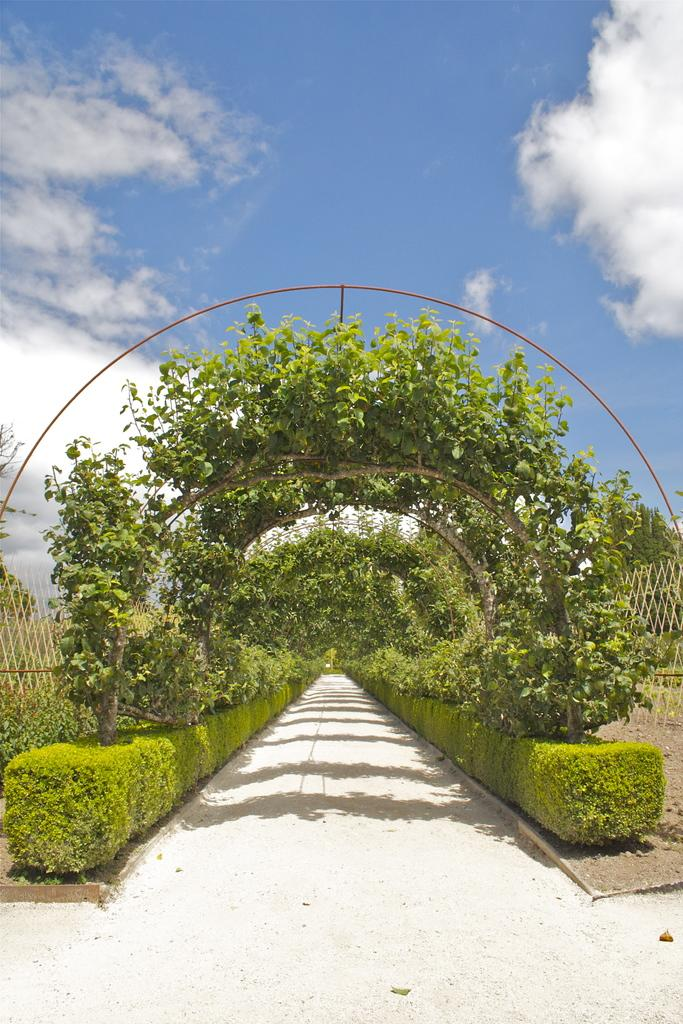What is at the bottom of the image? There is a floor at the bottom of the image. What can be seen in the background of the image? There are plants and trees in the background of the image. What is visible at the top of the image? The sky is visible at the top of the image. How would you describe the sky in the image? The sky appears to be cloudy. What type of pencil can be seen in the image? There is no pencil present in the image. What type of view can be seen from the image? The image itself provides a view of the floor, plants, trees, and sky, but it does not show a view from a specific location. 